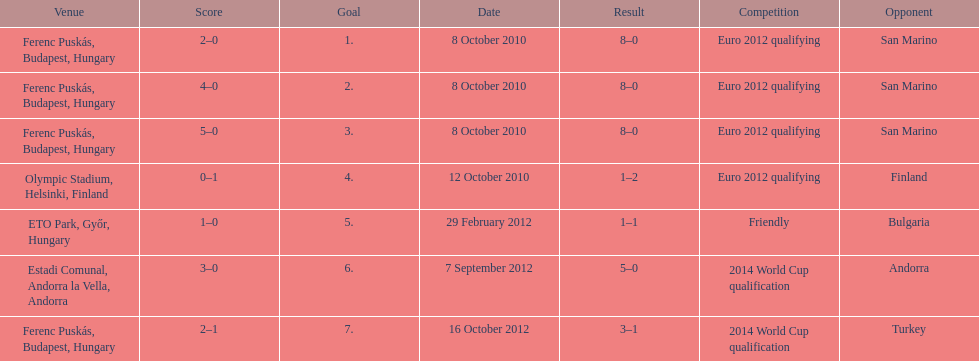Szalai tallied all but one of his international goals in either euro 2012 qualifying or what other phase of play? 2014 World Cup qualification. 